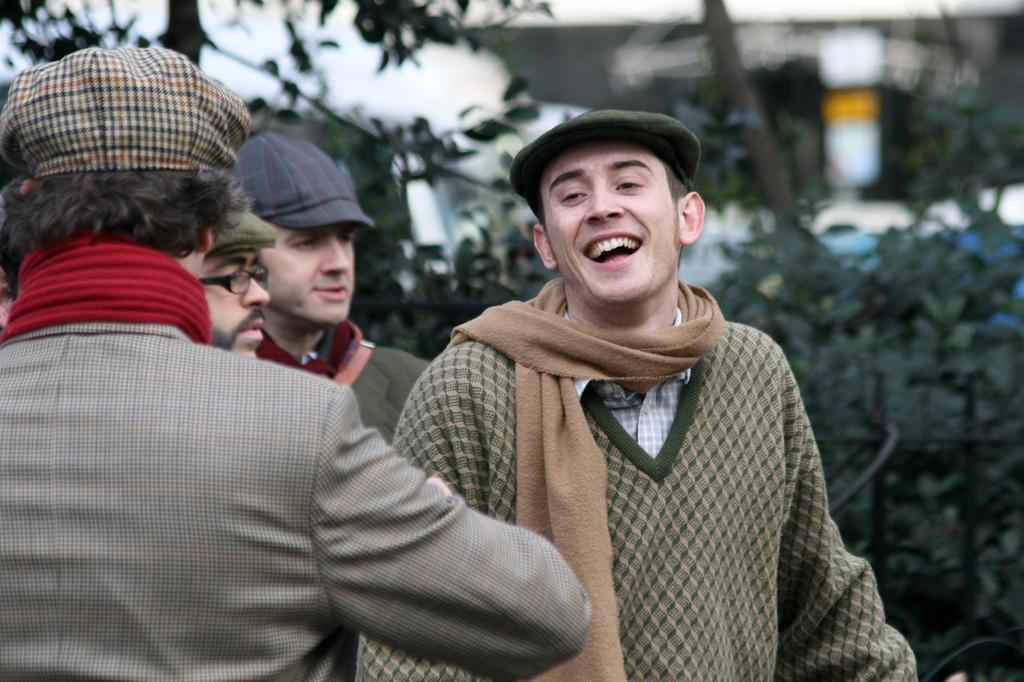How many people are in the image? There are four persons in the image. What clothing items are the persons wearing on their heads? The persons are wearing caps in the image. What clothing items are the persons wearing around their necks? The persons are wearing scarfs in the image. What type of clothing is covering their upper bodies? The persons are wearing sweaters in the image. What can be seen in the background of the image? There are trees and a building in the background of the image. What type of banana is being used as a prop in the image? There is no banana present in the image. What type of iron is visible in the image? There is no iron present in the image. 